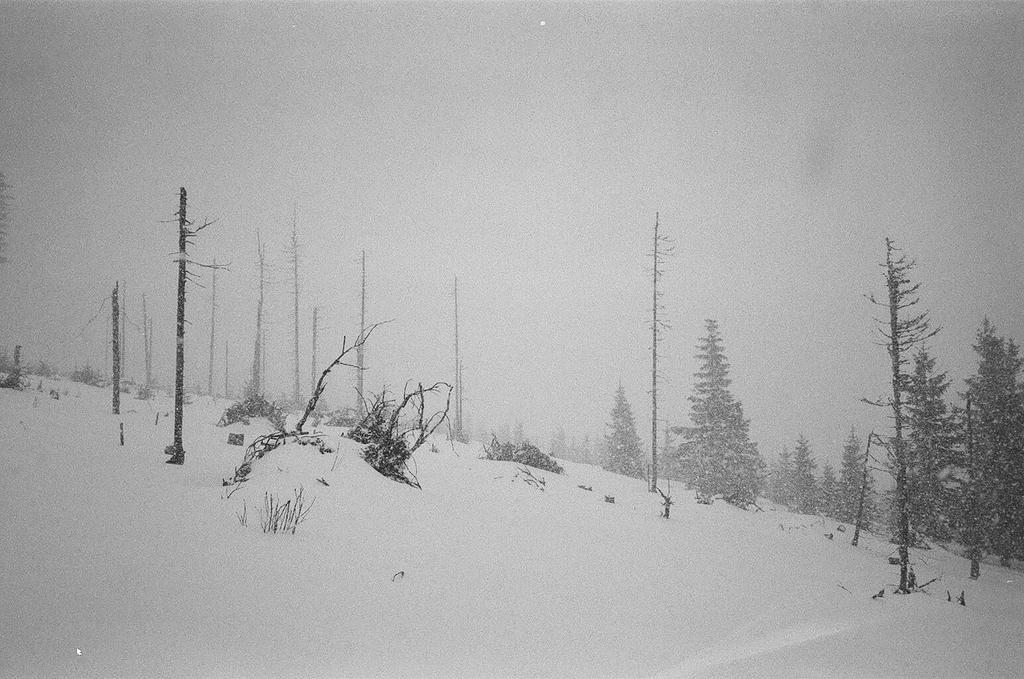Can you describe this image briefly? In this picture we can see trees, poles, plants, snow and in the background we can see the sky. 